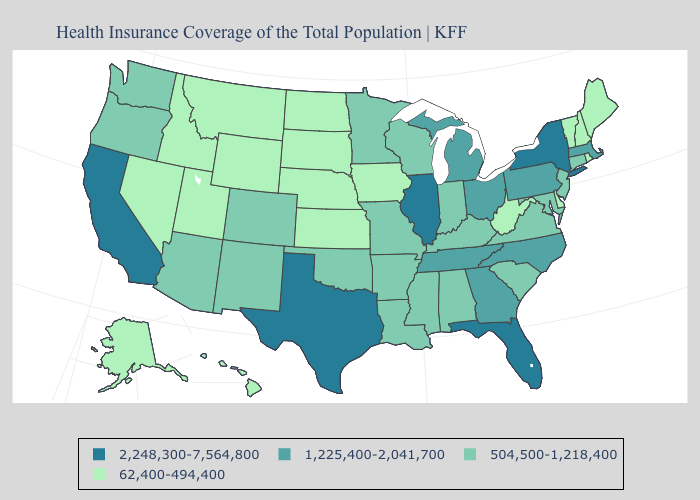Does the first symbol in the legend represent the smallest category?
Write a very short answer. No. Name the states that have a value in the range 504,500-1,218,400?
Give a very brief answer. Alabama, Arizona, Arkansas, Colorado, Connecticut, Indiana, Kentucky, Louisiana, Maryland, Minnesota, Mississippi, Missouri, New Jersey, New Mexico, Oklahoma, Oregon, South Carolina, Virginia, Washington, Wisconsin. Name the states that have a value in the range 504,500-1,218,400?
Keep it brief. Alabama, Arizona, Arkansas, Colorado, Connecticut, Indiana, Kentucky, Louisiana, Maryland, Minnesota, Mississippi, Missouri, New Jersey, New Mexico, Oklahoma, Oregon, South Carolina, Virginia, Washington, Wisconsin. What is the highest value in the Northeast ?
Be succinct. 2,248,300-7,564,800. What is the value of Ohio?
Be succinct. 1,225,400-2,041,700. Among the states that border Kansas , does Nebraska have the lowest value?
Quick response, please. Yes. Name the states that have a value in the range 2,248,300-7,564,800?
Quick response, please. California, Florida, Illinois, New York, Texas. Which states have the highest value in the USA?
Short answer required. California, Florida, Illinois, New York, Texas. Name the states that have a value in the range 1,225,400-2,041,700?
Write a very short answer. Georgia, Massachusetts, Michigan, North Carolina, Ohio, Pennsylvania, Tennessee. What is the highest value in the USA?
Short answer required. 2,248,300-7,564,800. What is the value of Massachusetts?
Give a very brief answer. 1,225,400-2,041,700. Among the states that border Massachusetts , which have the lowest value?
Answer briefly. New Hampshire, Rhode Island, Vermont. How many symbols are there in the legend?
Short answer required. 4. Does the first symbol in the legend represent the smallest category?
Keep it brief. No. What is the highest value in the USA?
Concise answer only. 2,248,300-7,564,800. 